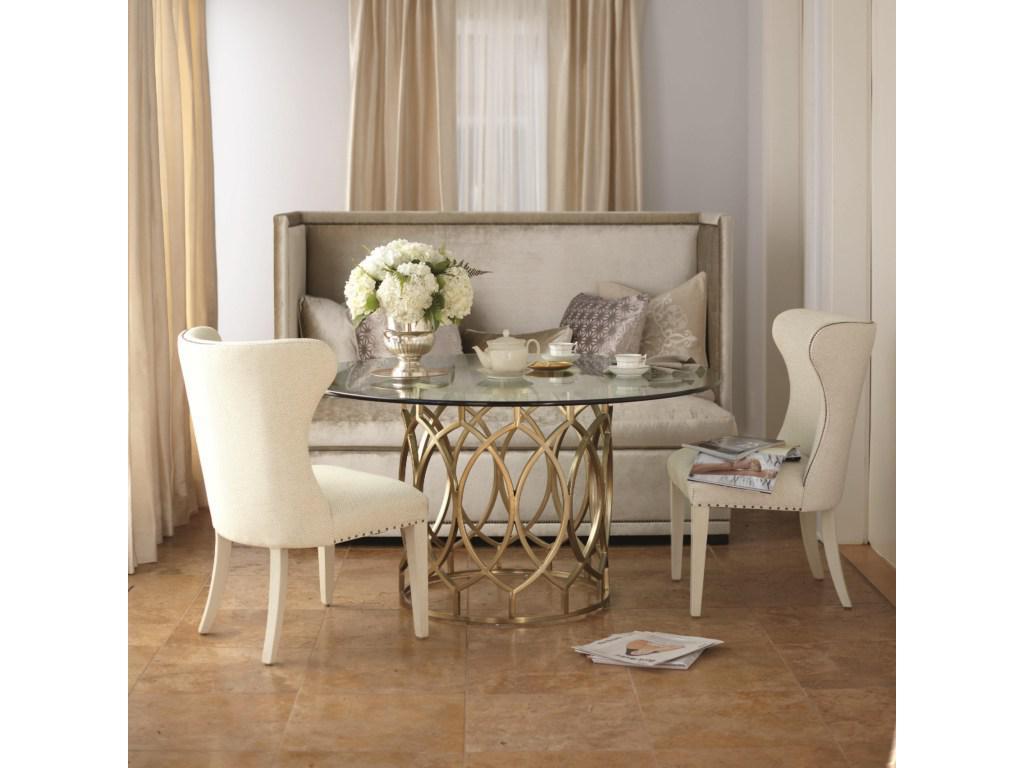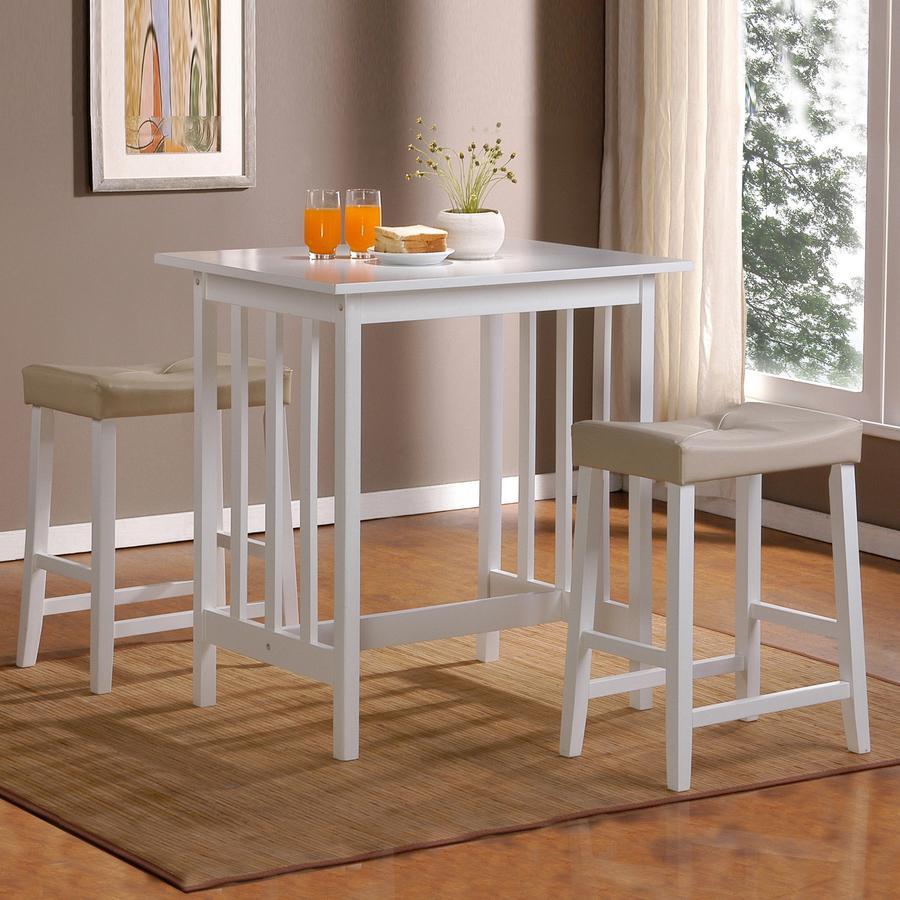The first image is the image on the left, the second image is the image on the right. Examine the images to the left and right. Is the description "One of the images shows a high top table with stools." accurate? Answer yes or no. Yes. 